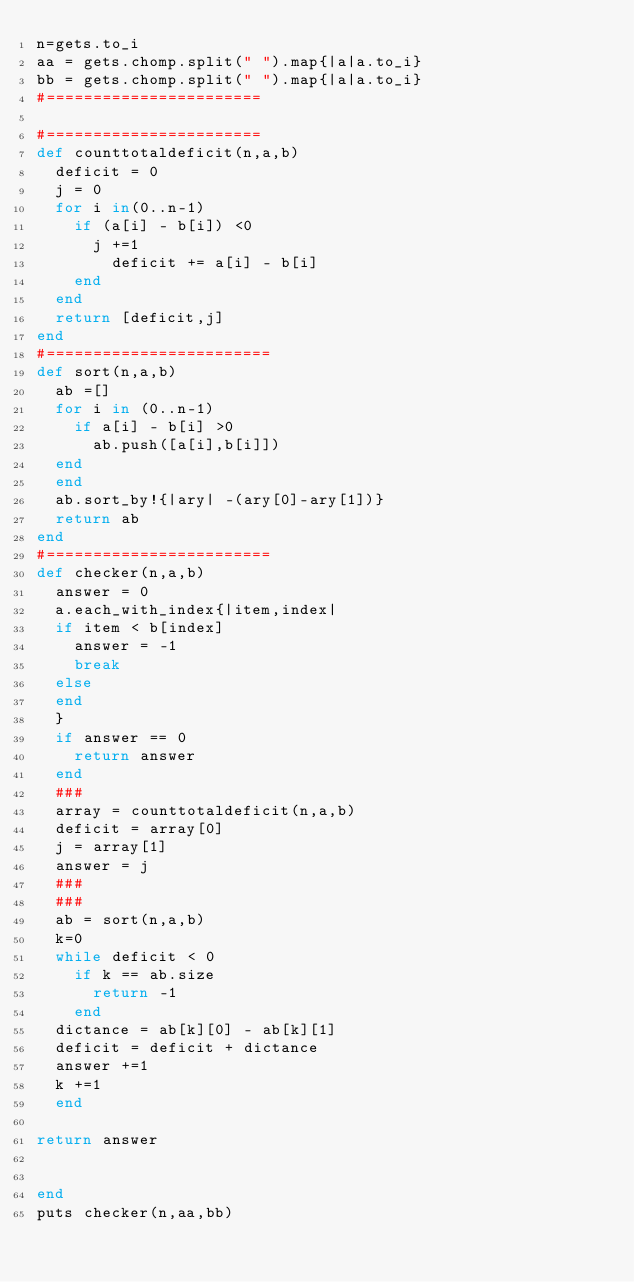<code> <loc_0><loc_0><loc_500><loc_500><_Ruby_>n=gets.to_i
aa = gets.chomp.split(" ").map{|a|a.to_i}
bb = gets.chomp.split(" ").map{|a|a.to_i}
#=======================

#=======================
def counttotaldeficit(n,a,b)
  deficit = 0
  j = 0
  for i in(0..n-1)
    if (a[i] - b[i]) <0
      j +=1
        deficit += a[i] - b[i]
    end
  end
  return [deficit,j]
end
#========================
def sort(n,a,b)
  ab =[]
  for i in (0..n-1)
    if a[i] - b[i] >0
      ab.push([a[i],b[i]])
  end
  end
  ab.sort_by!{|ary| -(ary[0]-ary[1])}
  return ab
end
#========================
def checker(n,a,b)
  answer = 0
  a.each_with_index{|item,index|
  if item < b[index]
    answer = -1
    break
  else
  end
  }
  if answer == 0
    return answer
  end
  ###
  array = counttotaldeficit(n,a,b)
  deficit = array[0]
  j = array[1]
  answer = j
  ###
  ###
  ab = sort(n,a,b)
  k=0
  while deficit < 0
    if k == ab.size
      return -1
    end
  dictance = ab[k][0] - ab[k][1]
  deficit = deficit + dictance
  answer +=1
  k +=1
  end

return answer


end
puts checker(n,aa,bb)
</code> 